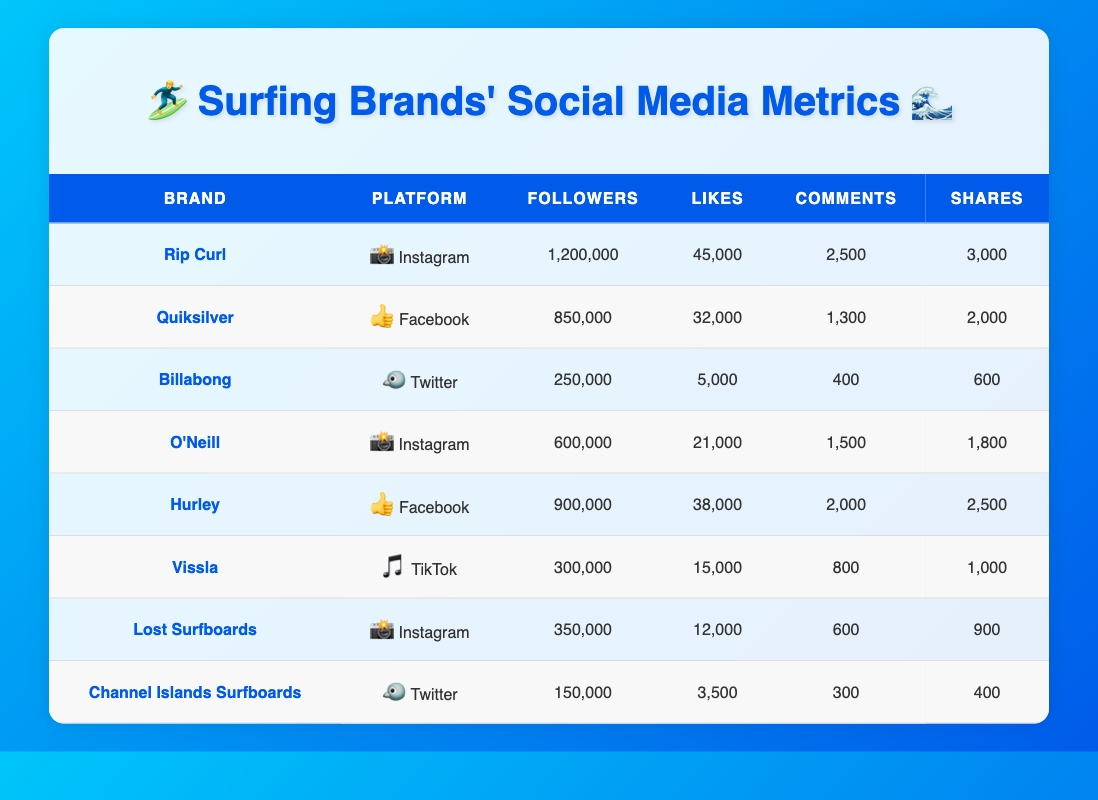What is the total number of followers for all brands on Instagram? To find the total number of followers on Instagram, we need to identify the brands using that platform. The brands are Rip Curl (1,200,000), O'Neill (600,000), and Lost Surfboards (350,000). Summing these up gives: 1,200,000 + 600,000 + 350,000 = 2,150,000.
Answer: 2,150,000 Which brand has the highest number of likes on Facebook? The brands listed on Facebook are Quiksilver with 32,000 likes and Hurley with 38,000 likes. Comparing these, Hurley has the highest likes with 38,000.
Answer: Hurley Is Vissla’s engagement on TikTok higher than Billabong's on Twitter? Vissla has 15,000 likes, 800 comments, and 1,000 shares on TikTok. Billabong has 5,000 likes, 400 comments, and 600 shares on Twitter. To determine higher engagement, sum the likes, comments, and shares for both platforms. Vissla: 15,000 + 800 + 1,000 = 16,800. Billabong: 5,000 + 400 + 600 = 6,000. Since 16,800 > 6,000, Vissla’s engagement is indeed higher.
Answer: Yes What is the average number of comments across all brands on Instagram? The brands on Instagram are Rip Curl (2,500 comments), O'Neill (1,500 comments), and Lost Surfboards (600 comments). The total comments are 2,500 + 1,500 + 600 = 4,600. There are three brands, so the average is 4,600 / 3 = 1,533.33.
Answer: 1,533.33 Does Billabong have more followers than Channel Islands Surfboards? Billabong has 250,000 followers, while Channel Islands Surfboards has 150,000 followers. Since 250,000 > 150,000, Billabong indeed has more followers.
Answer: Yes Which platform has the least number of likes? Looking at the likes for each platform, Instagram’s least likes are from Lost Surfboards with 12,000 likes, while Twitter has Billabong with 5,000 likes and Channel Islands Surfboards with 3,500 likes. Comparing these, 3,500 is the least.
Answer: Twitter How many more shares does Hurley have compared to Rip Curl? Hurley has 2,500 shares and Rip Curl has 3,000 shares. To find the difference: 3,000 - 2,500 = 500. Hurley has 500 shares fewer than Rip Curl.
Answer: 500 Which brand has the most total engagement (likes + comments + shares) overall? To find the brand with the highest total engagement, calculate the sum of likes, comments, and shares for all the brands. A few calculations show that Rip Curl has the highest total engagement of 1,200,000 + 45,000 + 2,500 + 3,000 = 1,250,500.
Answer: Rip Curl 